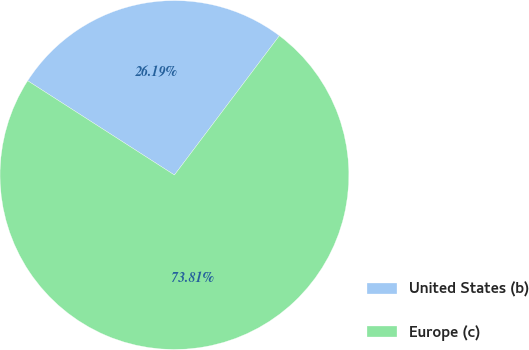Convert chart. <chart><loc_0><loc_0><loc_500><loc_500><pie_chart><fcel>United States (b)<fcel>Europe (c)<nl><fcel>26.19%<fcel>73.81%<nl></chart> 